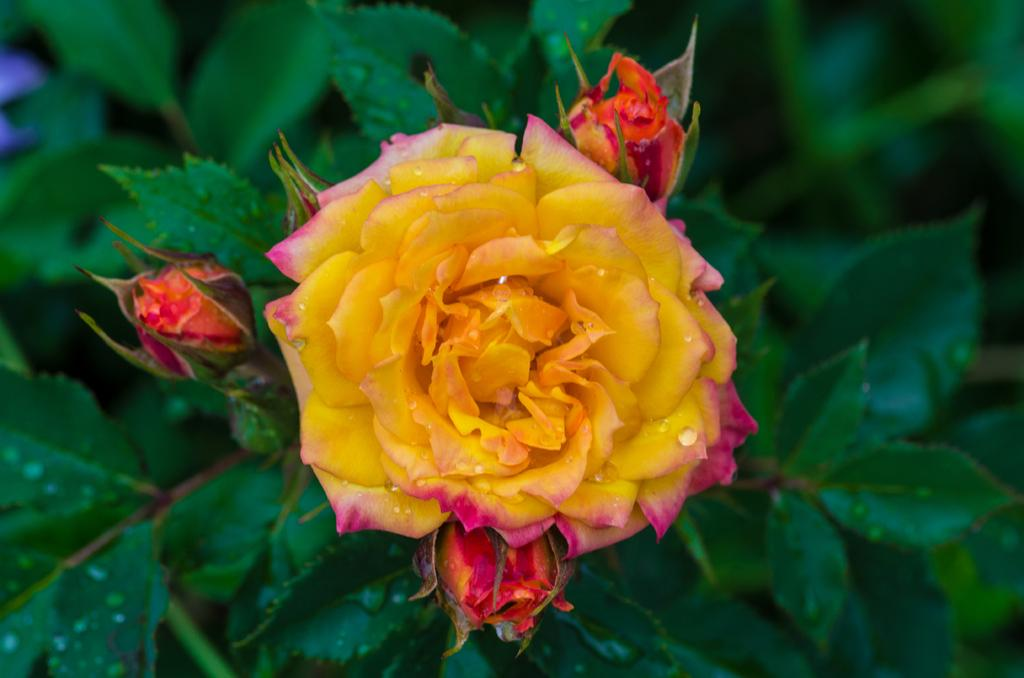What type of flower is in the image? There is a rose flower in the image. What stage of growth are the flowers on the plant in the image? There are buds on the plant in the image. What street is the bird flying over in the image? There is no bird or street present in the image; it only features a rose flower and buds on a plant. 